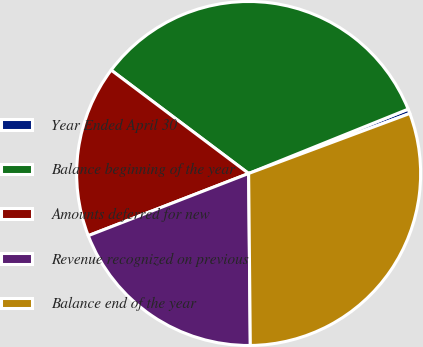Convert chart. <chart><loc_0><loc_0><loc_500><loc_500><pie_chart><fcel>Year Ended April 30<fcel>Balance beginning of the year<fcel>Amounts deferred for new<fcel>Revenue recognized on previous<fcel>Balance end of the year<nl><fcel>0.43%<fcel>33.64%<fcel>16.15%<fcel>19.27%<fcel>30.52%<nl></chart> 